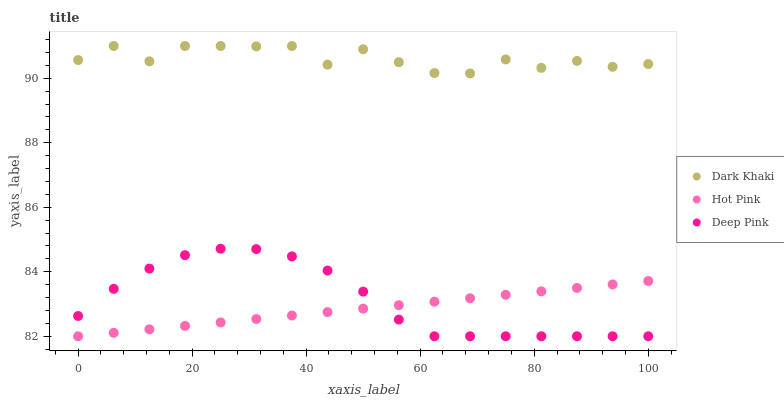Does Hot Pink have the minimum area under the curve?
Answer yes or no. Yes. Does Dark Khaki have the maximum area under the curve?
Answer yes or no. Yes. Does Deep Pink have the minimum area under the curve?
Answer yes or no. No. Does Deep Pink have the maximum area under the curve?
Answer yes or no. No. Is Hot Pink the smoothest?
Answer yes or no. Yes. Is Dark Khaki the roughest?
Answer yes or no. Yes. Is Deep Pink the smoothest?
Answer yes or no. No. Is Deep Pink the roughest?
Answer yes or no. No. Does Hot Pink have the lowest value?
Answer yes or no. Yes. Does Dark Khaki have the highest value?
Answer yes or no. Yes. Does Deep Pink have the highest value?
Answer yes or no. No. Is Deep Pink less than Dark Khaki?
Answer yes or no. Yes. Is Dark Khaki greater than Deep Pink?
Answer yes or no. Yes. Does Hot Pink intersect Deep Pink?
Answer yes or no. Yes. Is Hot Pink less than Deep Pink?
Answer yes or no. No. Is Hot Pink greater than Deep Pink?
Answer yes or no. No. Does Deep Pink intersect Dark Khaki?
Answer yes or no. No. 